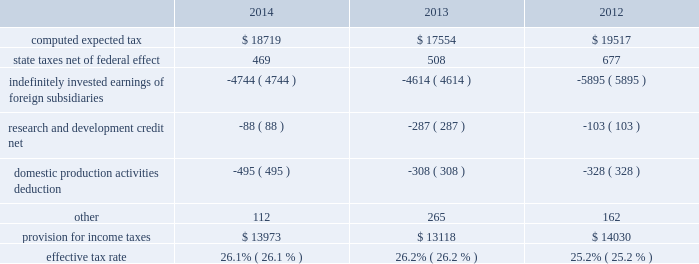Table of contents the foreign provision for income taxes is based on foreign pre-tax earnings of $ 33.6 billion , $ 30.5 billion and $ 36.8 billion in 2014 , 2013 and 2012 , respectively .
The company 2019s consolidated financial statements provide for any related tax liability on undistributed earnings that the company does not intend to be indefinitely reinvested outside the u.s .
Substantially all of the company 2019s undistributed international earnings intended to be indefinitely reinvested in operations outside the u.s .
Were generated by subsidiaries organized in ireland , which has a statutory tax rate of 12.5% ( 12.5 % ) .
As of september 27 , 2014 , u.s .
Income taxes have not been provided on a cumulative total of $ 69.7 billion of such earnings .
The amount of unrecognized deferred tax liability related to these temporary differences is estimated to be approximately $ 23.3 billion .
As of september 27 , 2014 and september 28 , 2013 , $ 137.1 billion and $ 111.3 billion , respectively , of the company 2019s cash , cash equivalents and marketable securities were held by foreign subsidiaries and are generally based in u.s .
Dollar-denominated holdings .
Amounts held by foreign subsidiaries are generally subject to u.s .
Income taxation on repatriation to the u.s .
A reconciliation of the provision for income taxes , with the amount computed by applying the statutory federal income tax rate ( 35% ( 35 % ) in 2014 , 2013 and 2012 ) to income before provision for income taxes for 2014 , 2013 and 2012 , is as follows ( dollars in millions ) : the company 2019s income taxes payable have been reduced by the tax benefits from employee stock plan awards .
For stock options , the company receives an income tax benefit calculated as the tax effect of the difference between the fair market value of the stock issued at the time of the exercise and the exercise price .
For rsus , the company receives an income tax benefit upon the award 2019s vesting equal to the tax effect of the underlying stock 2019s fair market value .
The company had net excess tax benefits from equity awards of $ 706 million , $ 643 million and $ 1.4 billion in 2014 , 2013 and 2012 , respectively , which were reflected as increases to common stock .
Apple inc .
| 2014 form 10-k | 64 .

What was the highest effective tax rate , as a percentage? 
Computations: table_max(effective tax rate, none)
Answer: 0.262. Table of contents the foreign provision for income taxes is based on foreign pre-tax earnings of $ 33.6 billion , $ 30.5 billion and $ 36.8 billion in 2014 , 2013 and 2012 , respectively .
The company 2019s consolidated financial statements provide for any related tax liability on undistributed earnings that the company does not intend to be indefinitely reinvested outside the u.s .
Substantially all of the company 2019s undistributed international earnings intended to be indefinitely reinvested in operations outside the u.s .
Were generated by subsidiaries organized in ireland , which has a statutory tax rate of 12.5% ( 12.5 % ) .
As of september 27 , 2014 , u.s .
Income taxes have not been provided on a cumulative total of $ 69.7 billion of such earnings .
The amount of unrecognized deferred tax liability related to these temporary differences is estimated to be approximately $ 23.3 billion .
As of september 27 , 2014 and september 28 , 2013 , $ 137.1 billion and $ 111.3 billion , respectively , of the company 2019s cash , cash equivalents and marketable securities were held by foreign subsidiaries and are generally based in u.s .
Dollar-denominated holdings .
Amounts held by foreign subsidiaries are generally subject to u.s .
Income taxation on repatriation to the u.s .
A reconciliation of the provision for income taxes , with the amount computed by applying the statutory federal income tax rate ( 35% ( 35 % ) in 2014 , 2013 and 2012 ) to income before provision for income taxes for 2014 , 2013 and 2012 , is as follows ( dollars in millions ) : the company 2019s income taxes payable have been reduced by the tax benefits from employee stock plan awards .
For stock options , the company receives an income tax benefit calculated as the tax effect of the difference between the fair market value of the stock issued at the time of the exercise and the exercise price .
For rsus , the company receives an income tax benefit upon the award 2019s vesting equal to the tax effect of the underlying stock 2019s fair market value .
The company had net excess tax benefits from equity awards of $ 706 million , $ 643 million and $ 1.4 billion in 2014 , 2013 and 2012 , respectively , which were reflected as increases to common stock .
Apple inc .
| 2014 form 10-k | 64 .

What is the average effective tax rate for the 3 years ended 2014? 
Computations: (((26.1 + 26.2) + 25.2) / 3)
Answer: 25.83333. Table of contents the foreign provision for income taxes is based on foreign pre-tax earnings of $ 33.6 billion , $ 30.5 billion and $ 36.8 billion in 2014 , 2013 and 2012 , respectively .
The company 2019s consolidated financial statements provide for any related tax liability on undistributed earnings that the company does not intend to be indefinitely reinvested outside the u.s .
Substantially all of the company 2019s undistributed international earnings intended to be indefinitely reinvested in operations outside the u.s .
Were generated by subsidiaries organized in ireland , which has a statutory tax rate of 12.5% ( 12.5 % ) .
As of september 27 , 2014 , u.s .
Income taxes have not been provided on a cumulative total of $ 69.7 billion of such earnings .
The amount of unrecognized deferred tax liability related to these temporary differences is estimated to be approximately $ 23.3 billion .
As of september 27 , 2014 and september 28 , 2013 , $ 137.1 billion and $ 111.3 billion , respectively , of the company 2019s cash , cash equivalents and marketable securities were held by foreign subsidiaries and are generally based in u.s .
Dollar-denominated holdings .
Amounts held by foreign subsidiaries are generally subject to u.s .
Income taxation on repatriation to the u.s .
A reconciliation of the provision for income taxes , with the amount computed by applying the statutory federal income tax rate ( 35% ( 35 % ) in 2014 , 2013 and 2012 ) to income before provision for income taxes for 2014 , 2013 and 2012 , is as follows ( dollars in millions ) : the company 2019s income taxes payable have been reduced by the tax benefits from employee stock plan awards .
For stock options , the company receives an income tax benefit calculated as the tax effect of the difference between the fair market value of the stock issued at the time of the exercise and the exercise price .
For rsus , the company receives an income tax benefit upon the award 2019s vesting equal to the tax effect of the underlying stock 2019s fair market value .
The company had net excess tax benefits from equity awards of $ 706 million , $ 643 million and $ 1.4 billion in 2014 , 2013 and 2012 , respectively , which were reflected as increases to common stock .
Apple inc .
| 2014 form 10-k | 64 .

What was the change between september 27 , 2014 and september 28 , 2013 of the company 2019s cash , cash equivalents and marketable securities held by foreign subsidiaries based in u.s . dollar-denominated holdings , in billions? 
Computations: (137.1 - 111.3)
Answer: 25.8. 